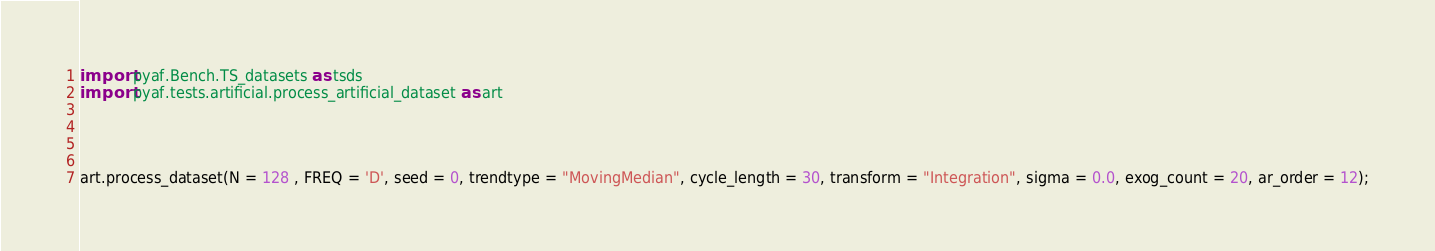<code> <loc_0><loc_0><loc_500><loc_500><_Python_>import pyaf.Bench.TS_datasets as tsds
import pyaf.tests.artificial.process_artificial_dataset as art




art.process_dataset(N = 128 , FREQ = 'D', seed = 0, trendtype = "MovingMedian", cycle_length = 30, transform = "Integration", sigma = 0.0, exog_count = 20, ar_order = 12);</code> 